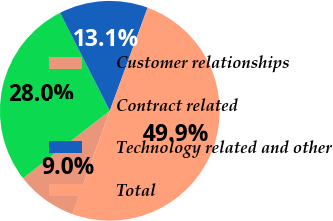<chart> <loc_0><loc_0><loc_500><loc_500><pie_chart><fcel>Customer relationships<fcel>Contract related<fcel>Technology related and other<fcel>Total<nl><fcel>8.97%<fcel>28.04%<fcel>13.07%<fcel>49.92%<nl></chart> 